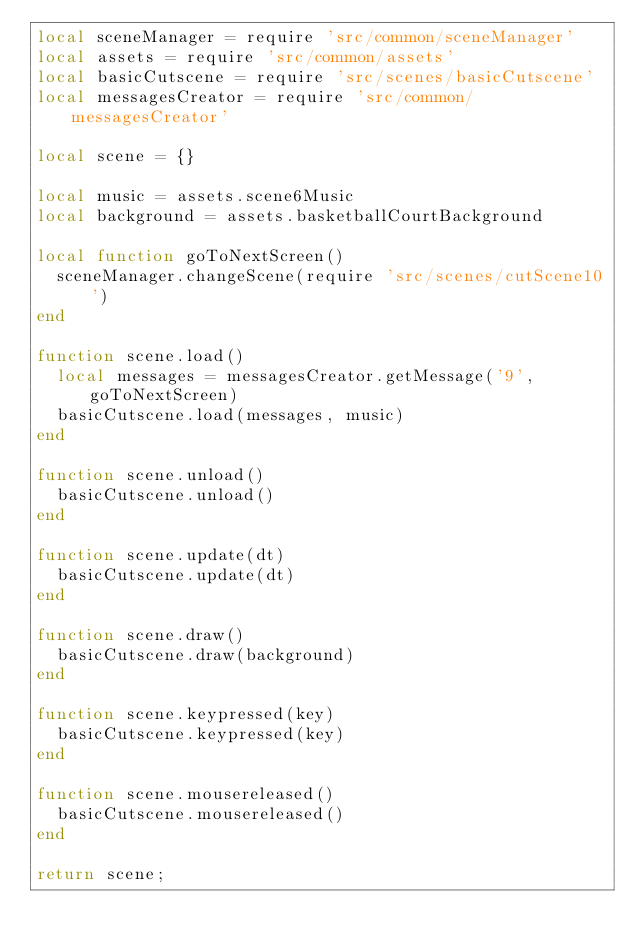<code> <loc_0><loc_0><loc_500><loc_500><_Lua_>local sceneManager = require 'src/common/sceneManager'
local assets = require 'src/common/assets'
local basicCutscene = require 'src/scenes/basicCutscene'
local messagesCreator = require 'src/common/messagesCreator'

local scene = {}

local music = assets.scene6Music
local background = assets.basketballCourtBackground

local function goToNextScreen()
  sceneManager.changeScene(require 'src/scenes/cutScene10')
end

function scene.load()
  local messages = messagesCreator.getMessage('9', goToNextScreen)
  basicCutscene.load(messages, music)
end

function scene.unload()
  basicCutscene.unload()
end

function scene.update(dt)
  basicCutscene.update(dt)
end

function scene.draw()
  basicCutscene.draw(background)
end

function scene.keypressed(key)
  basicCutscene.keypressed(key)
end

function scene.mousereleased()
  basicCutscene.mousereleased()
end

return scene;
</code> 